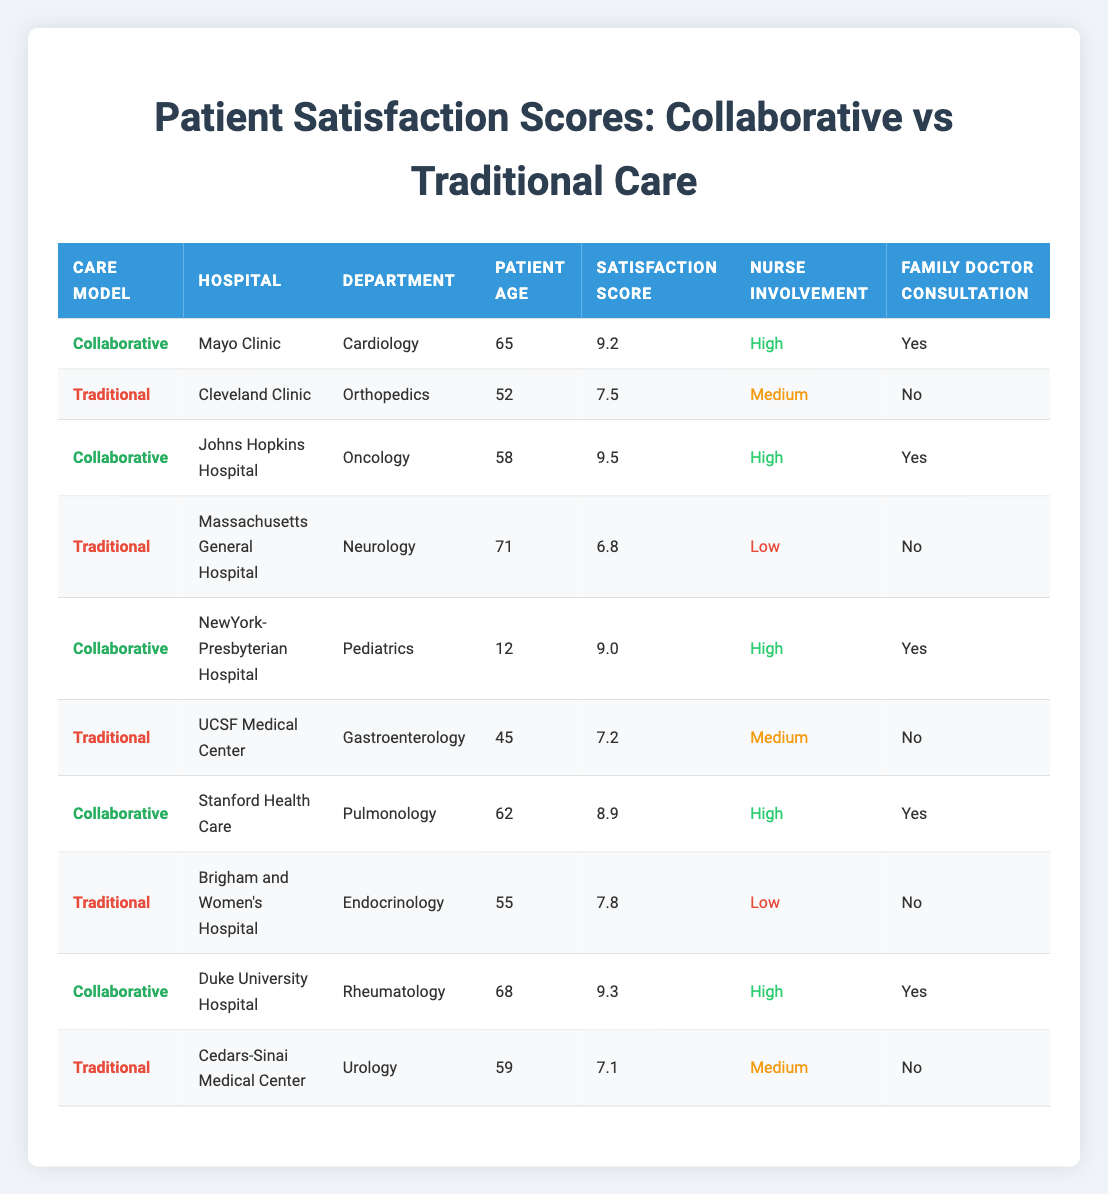What is the highest patient satisfaction score recorded in the collaborative care model? The highest satisfaction score in the collaborative care model can be found by looking at the scores in the table. The scores for the collaborative care patients are 9.2, 9.5, 9.0, 9.3. Among these, 9.5 is the highest score.
Answer: 9.5 How many hospitals provided traditional care? By reviewing the table, we can identify the rows corresponding to the traditional care model. There are four entries for traditional care under the hospitals Cleveland Clinic, Massachusetts General Hospital, UCSF Medical Center, and Cedars-Sinai Medical Center. Thus, the total number of hospitals is four.
Answer: 4 What is the average satisfaction score for the collaborative care model? To calculate the average satisfaction score, we take all the satisfaction scores from the collaborative care rows: (9.2 + 9.5 + 9.0 + 9.3) = 37. Then, divide by the number of collaborative care instances, which is 4. Thus, 37/4 = 9.25 for the average satisfaction score.
Answer: 9.25 Did all patients who had high nurse involvement also consult with a family doctor? By examining the table under the high nurse involvement category, we see that all collaborative care instances with high nurse involvement (Mayo Clinic, Johns Hopkins Hospital, NewYork-Presbyterian Hospital, Duke University Hospital) also had a family doctor consultation listed as "Yes." Thus, the statement is true.
Answer: Yes Which care model had a higher number of hospitals with low nurse involvement? In the table, the traditional care model has two hospitals (Massachusetts General Hospital and Brigham and Women's Hospital) with low nurse involvement. The collaborative model has none. Therefore, traditional care has a higher count of hospitals with low nurse involvement.
Answer: Traditional What is the average satisfaction score for patients in traditional care? The satisfaction scores for the traditional care model are 7.5, 6.8, 7.2, and 7.1. To find the average, sum these scores: (7.5 + 6.8 + 7.2 + 7.1) = 28.6. Then divide by the number of traditional care instances, which is 4. So, 28.6/4 = 7.15 for the average satisfaction score.
Answer: 7.15 Is the patient satisfaction score for Duke University Hospital higher than the average score for traditional care? First, Duke University Hospital has a satisfaction score of 9.3. From previous calculations, the average for traditional care is 7.15. Since 9.3 is greater than 7.15, the answer to the question is yes.
Answer: Yes Counting the number of hospitals with family doctor consultations, how many offered collaborative care compared to traditional care? In the table, collaborative care hospitals with family doctor consultations are four: Mayo Clinic, Johns Hopkins Hospital, NewYork-Presbyterian Hospital, and Duke University Hospital. In contrast, traditional care has no hospitals listed that consulted with family doctors. Therefore, collaborative care has more hospitals with consultations.
Answer: Collaborative care What is the satisfaction score difference between the highest and lowest for traditional care? The highest satisfaction score for traditional care is 7.8 (Brigham and Women's Hospital), and the lowest is 6.8 (Massachusetts General Hospital). To find the difference, calculate 7.8 - 6.8 = 1.0.
Answer: 1.0 